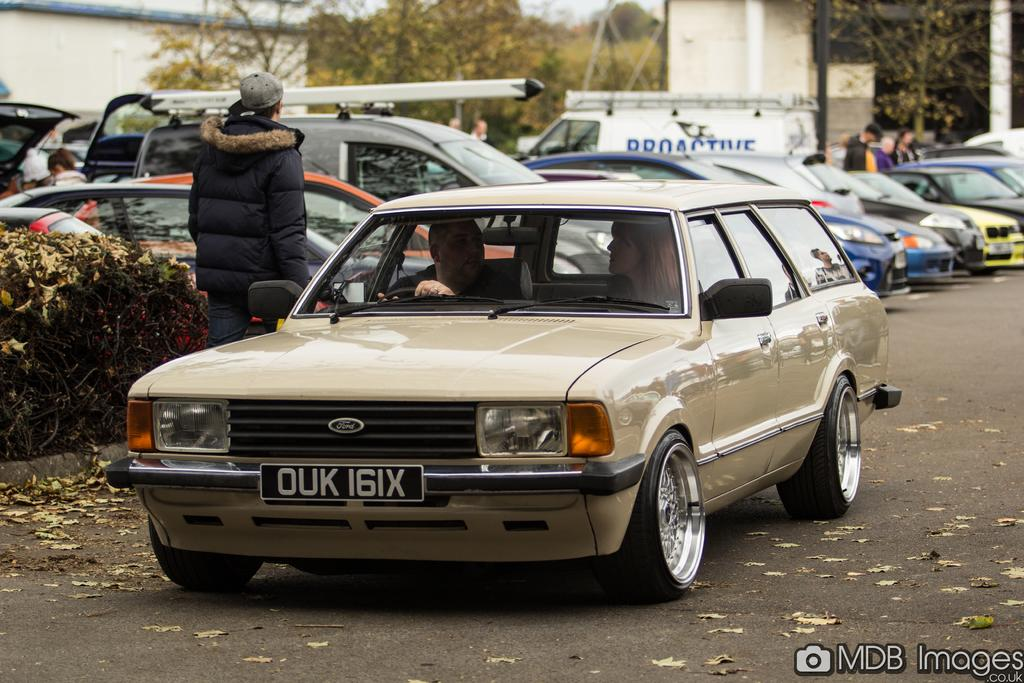What is the person in the image doing? The person is standing in the image. What is the person wearing? The person is wearing a jacket. What else can be seen in the image besides the person? There are vehicles, plants, trees, and a building in the distance. Can you describe the vehicles in the image? There are vehicles in the image, and inside one of them, there are 2 persons sitting. What type of vegetation is present in the image? There are plants and trees in the image. What thought is the person having about the flag in the image? There is no flag present in the image, so it is not possible to determine any thoughts the person might have about a flag. 